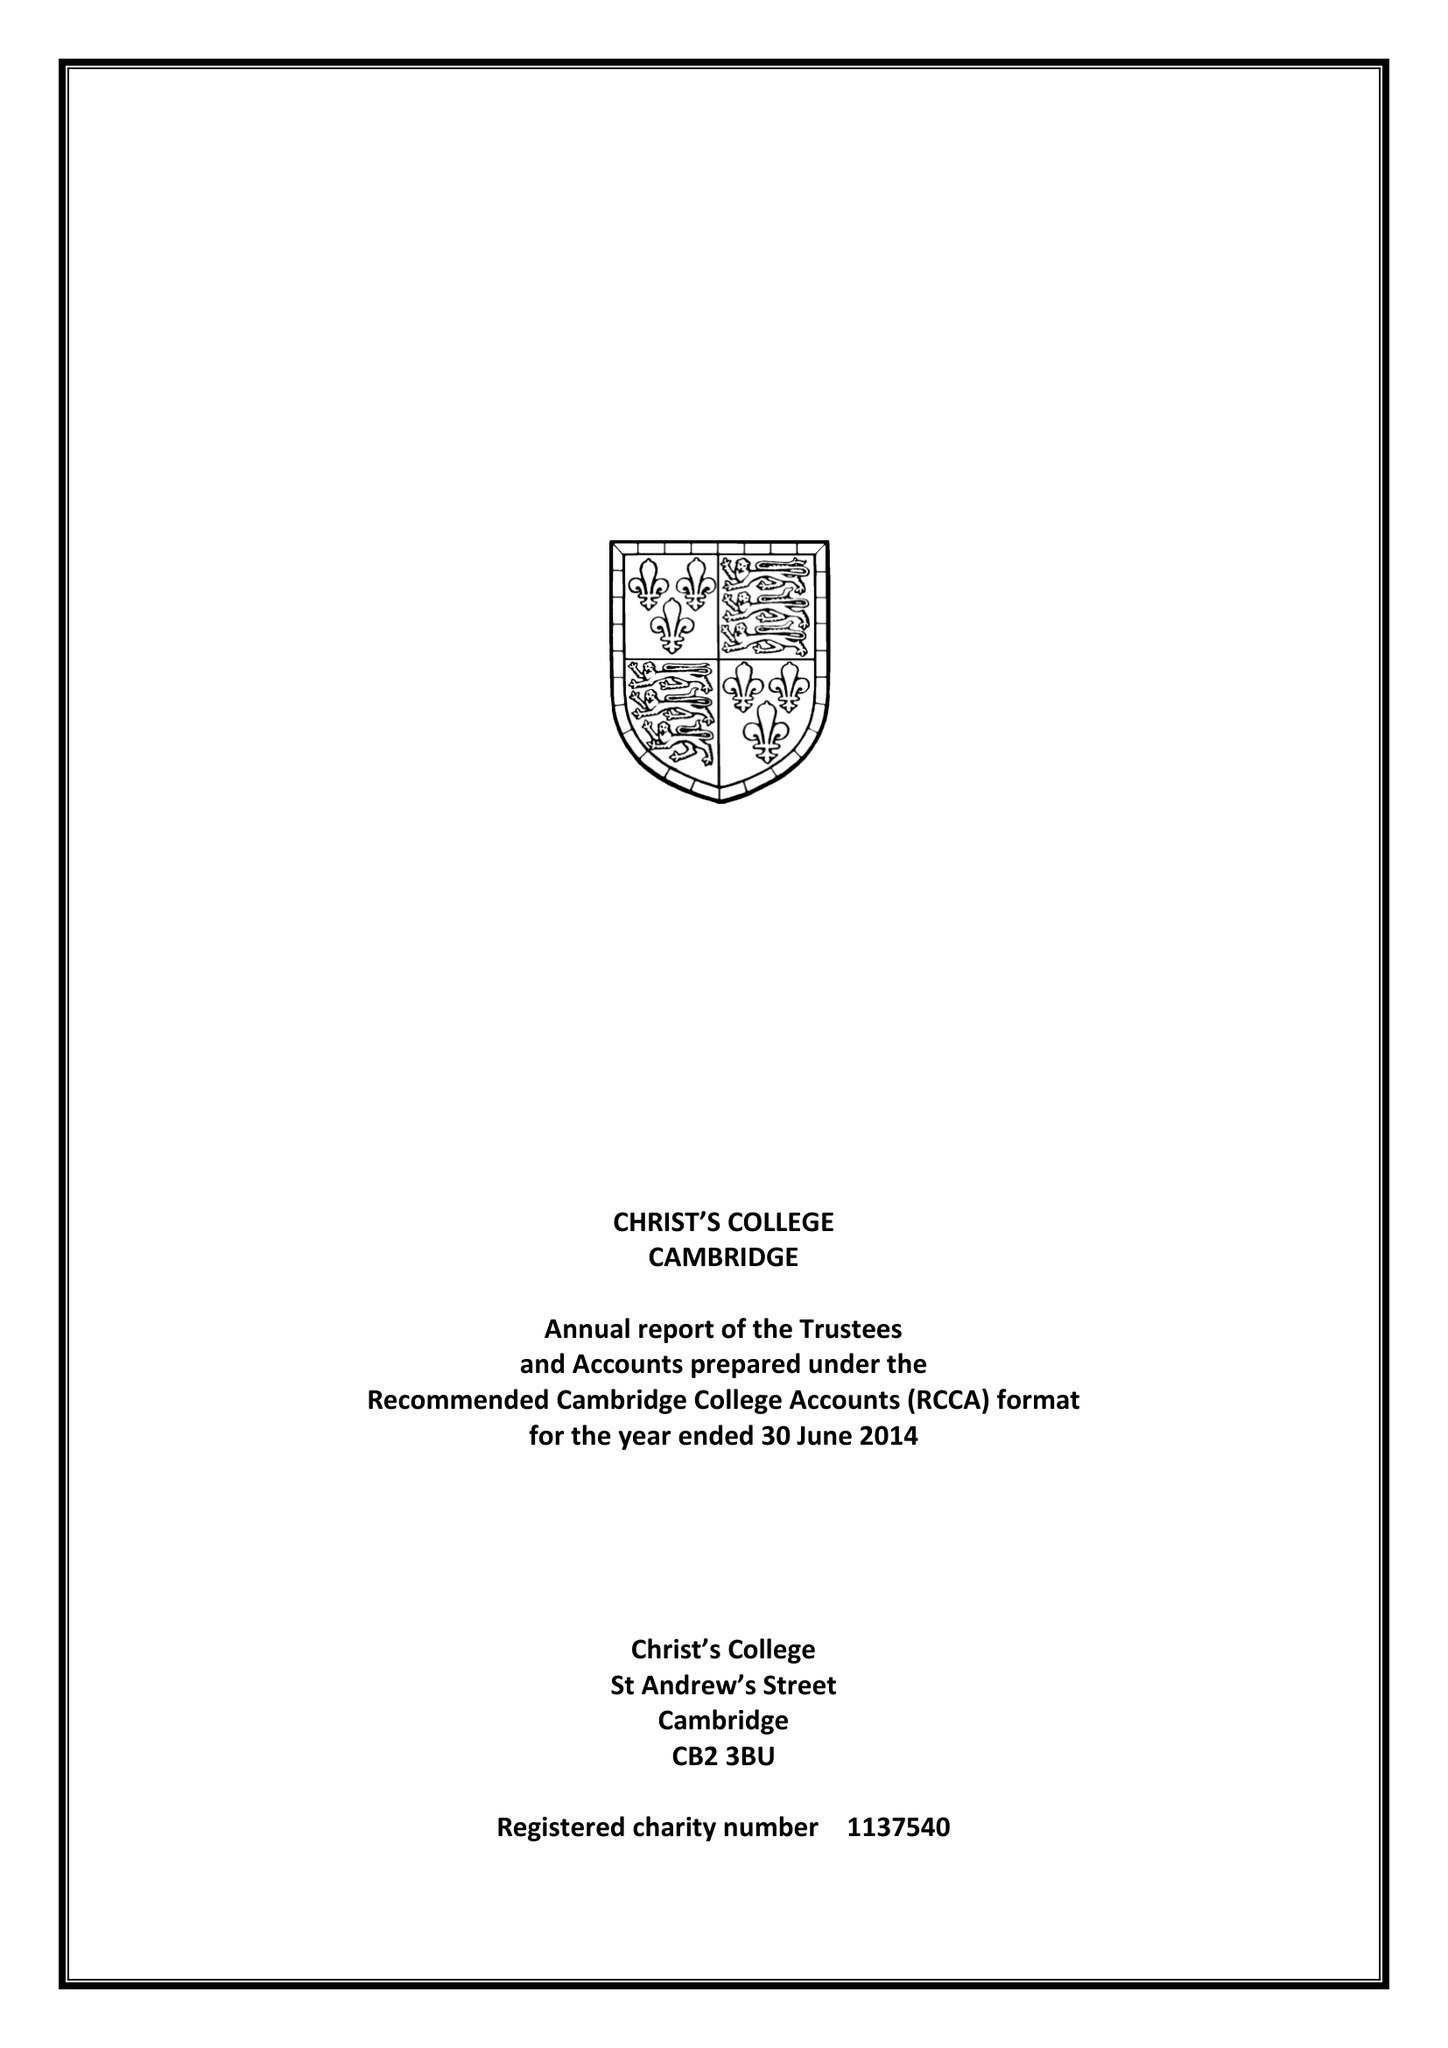What is the value for the charity_number?
Answer the question using a single word or phrase. 1137540 